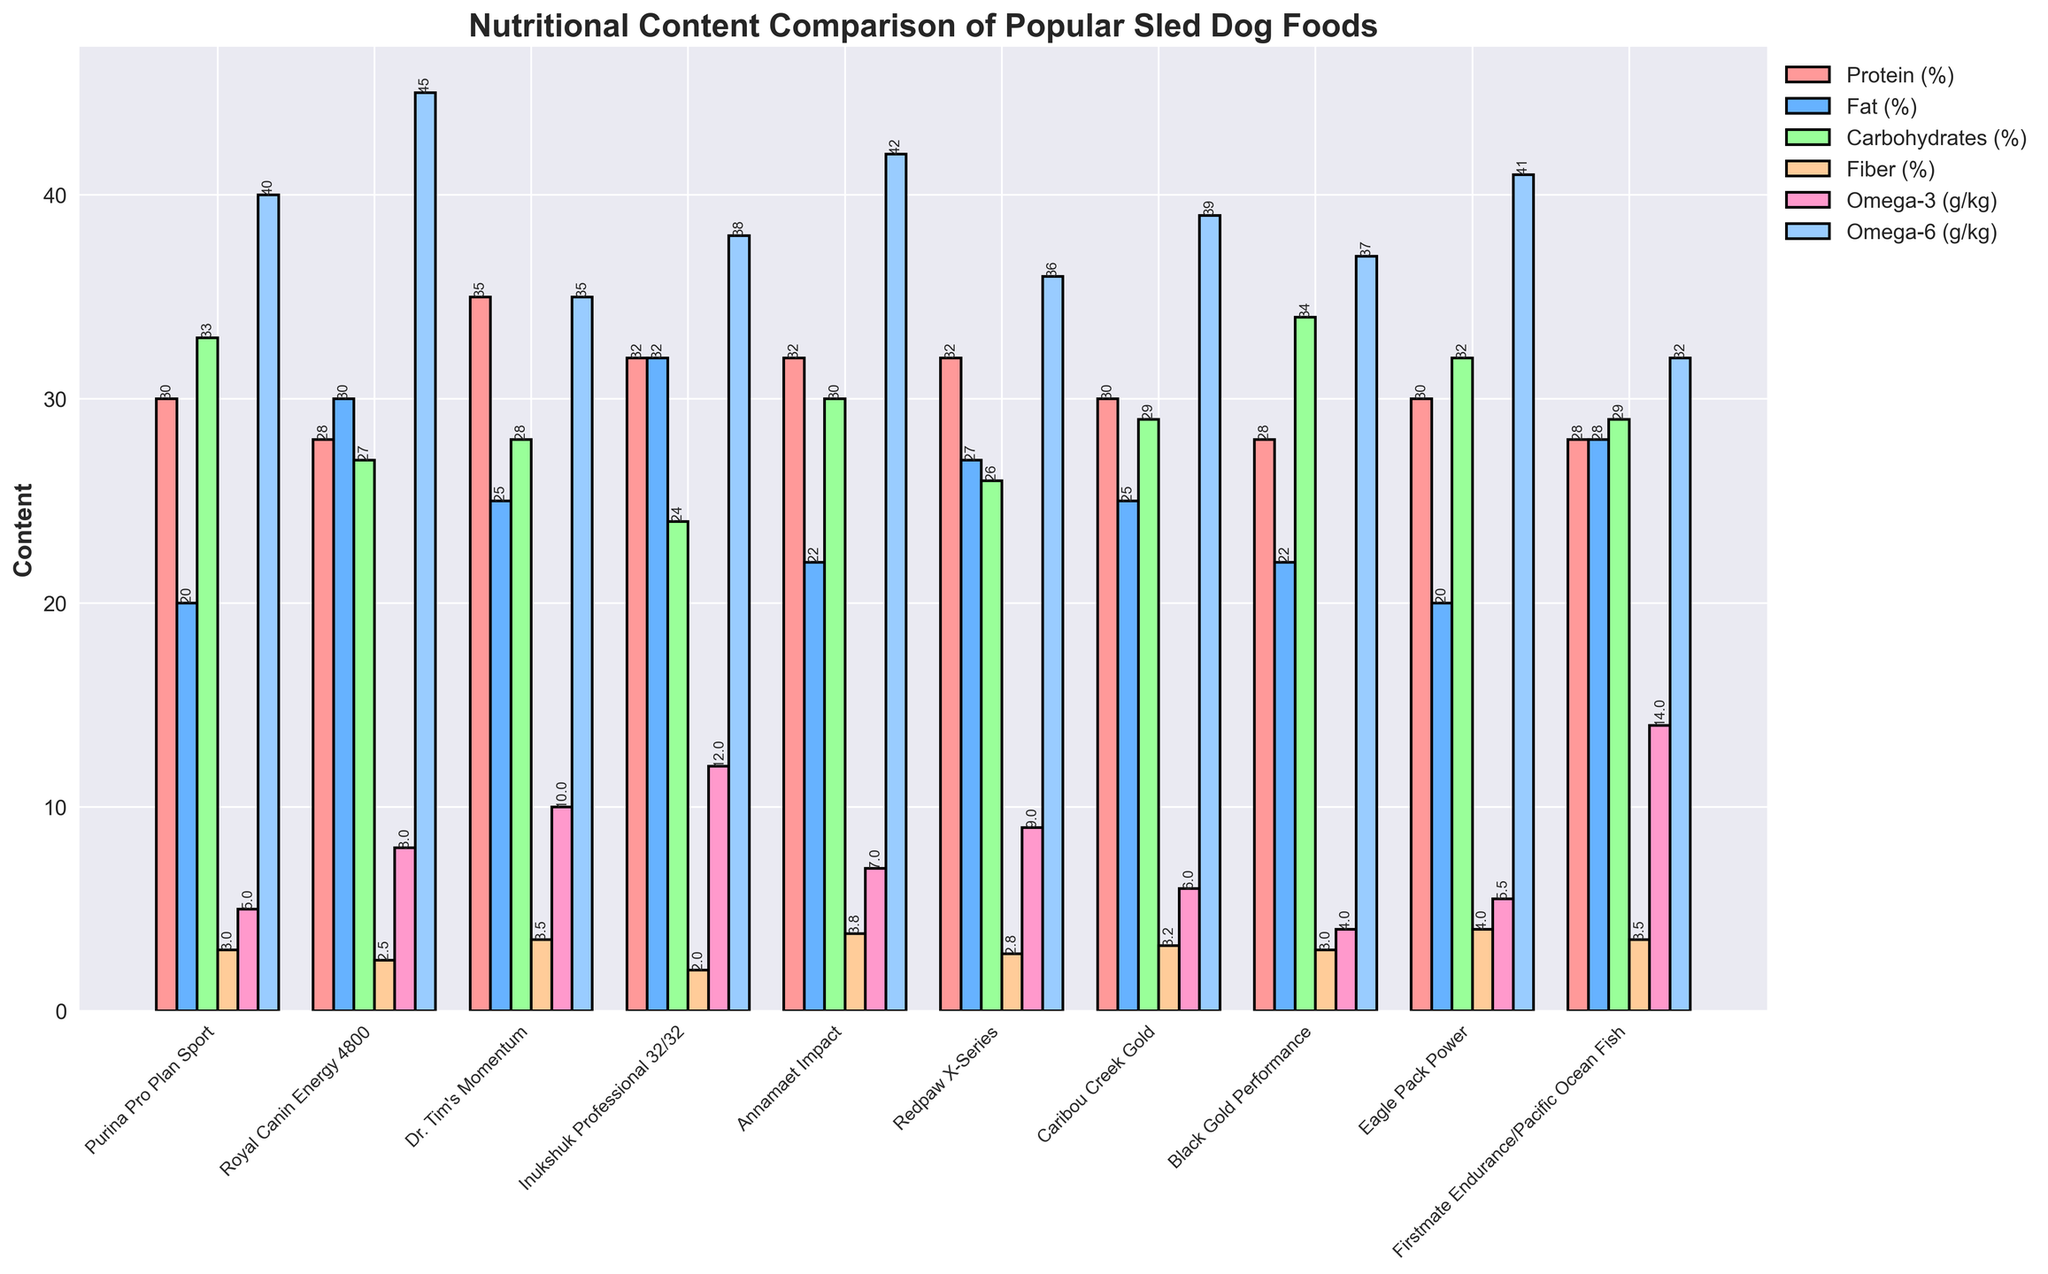What's the average percentage of Protein content across all brands? To find the average Protein percentage, we add the protein values for each brand and divide by the total number of brands. Sum: (30 + 28 + 35 + 32 + 32 + 32 + 30 + 28 + 30 + 28) = 305. Number of brands = 10. Average = 305 / 10 = 30.5
Answer: 30.5 Which brand has the highest Omega-3 content? Reviewing the Omega-3 content for each brand, the highest value is 14 g/kg found in Firstmate Endurance/Pacific Ocean Fish.
Answer: Firstmate Endurance/Pacific Ocean Fish Among the listed brands, which has the lowest Fiber content and what is its value? Checking the Fiber content for each brand, the lowest value is 2%, found in Inukshuk Professional 32/32 and Royal Canin Energy 4800.
Answer: Inukshuk Professional 32/32 and Royal Canin Energy 4800, 2% Compare the Fat content of Dr. Tim's Momentum and Eagle Pack Power. Which one has a higher Fat content and by how much? Dr. Tim's Momentum has a Fat content of 25%, while Eagle Pack Power has a Fat content of 20%. Difference = 25% - 20% = 5%. Dr. Tim's Momentum has a higher Fat content by 5%.
Answer: Dr. Tim's Momentum by 5% What is the total Omega-6 content across all brands? Adding the Omega-6 content of each brand: (40 + 45 + 35 + 38 + 42 + 36 + 39 + 37 + 41 + 32) = 385 g/kg.
Answer: 385 Is there any brand with equal Fat and Omega-6 content? Reviewing the Fat and Omega-6 values, we find that no brand has the same value for both Fat and Omega-6 content.
Answer: No What is the difference in Carbohydrates content between the brand with the highest and the brand with the lowest Carbohydrates content? The brand with the highest Carbohydrates content is Black Gold Performance at 34%, and the brand with the lowest is Inukshuk Professional 32/32 at 24%. Difference = 34% - 24% = 10%.
Answer: 10 List the brands with Protein content above 30%. Checking which brands have Protein content above 30%, we find: Dr. Tim's Momentum (35%), Inukshuk Professional 32/32 (32%), Annamaet Impact (32%), Redpaw X-Series (32%).
Answer: Dr. Tim's Momentum, Inukshuk Professional 32/32, Annamaet Impact, Redpaw X-Series How many brands have an Omega-3 content less than 7 g/kg? Counting the brands with Omega-3 content less than 7 g/kg: Purina Pro Plan Sport (5), Caribou Creek Gold (6), Black Gold Performance (4), Eagle Pack Power (5.5), and Annamaet Impact (7) is excluded. So there are 4 brands.
Answer: 4 Which nutrient varies the most among the brands in terms of percentage? By visually inspecting the varying heights of the bars representing each nutrient, Protein (%) shows the highest variation from 28% to 35%.
Answer: Protein 